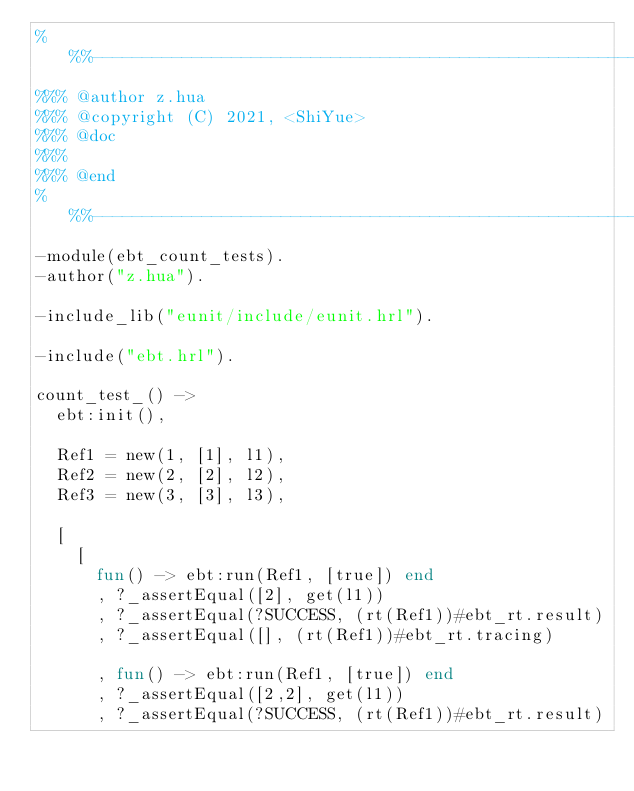<code> <loc_0><loc_0><loc_500><loc_500><_Erlang_>%%%-------------------------------------------------------------------
%%% @author z.hua
%%% @copyright (C) 2021, <ShiYue>
%%% @doc
%%%
%%% @end
%%%-------------------------------------------------------------------
-module(ebt_count_tests).
-author("z.hua").

-include_lib("eunit/include/eunit.hrl").

-include("ebt.hrl").

count_test_() ->
  ebt:init(),

  Ref1 = new(1, [1], l1),
  Ref2 = new(2, [2], l2),
  Ref3 = new(3, [3], l3),

  [
    [
      fun() -> ebt:run(Ref1, [true]) end
      , ?_assertEqual([2], get(l1))
      , ?_assertEqual(?SUCCESS, (rt(Ref1))#ebt_rt.result)
      , ?_assertEqual([], (rt(Ref1))#ebt_rt.tracing)

      , fun() -> ebt:run(Ref1, [true]) end
      , ?_assertEqual([2,2], get(l1))
      , ?_assertEqual(?SUCCESS, (rt(Ref1))#ebt_rt.result)</code> 